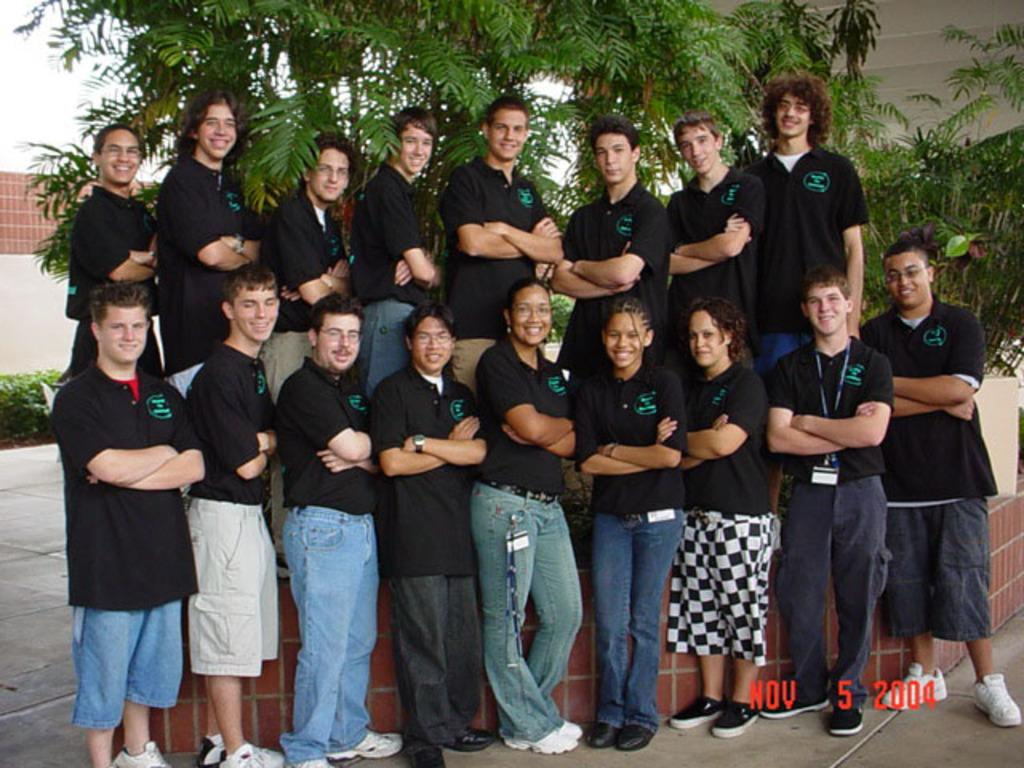How are the people arranged in the image? The people are standing in two rows. What are the people wearing in the image? The people are wearing black t-shirts. What can be seen in the background of the image? There are trees at the back of the scene. What type of dress is being worn by the person in the front row? There is no mention of a dress in the image; the people are wearing black t-shirts. 